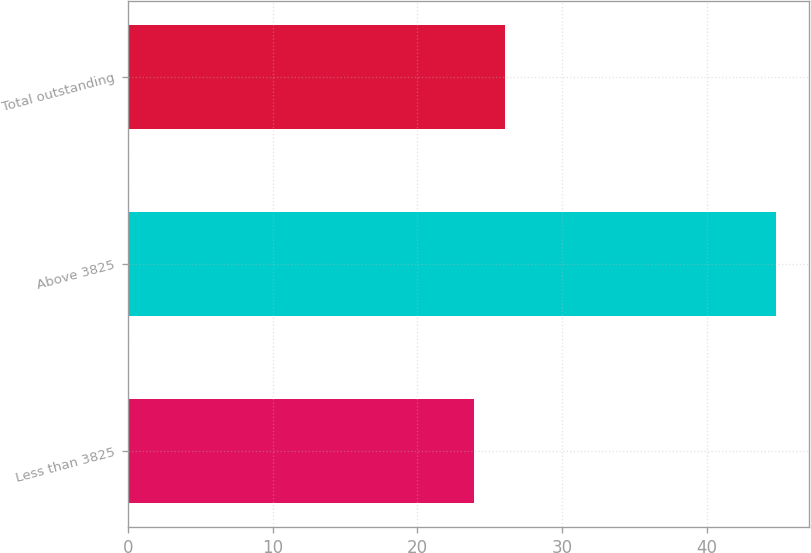<chart> <loc_0><loc_0><loc_500><loc_500><bar_chart><fcel>Less than 3825<fcel>Above 3825<fcel>Total outstanding<nl><fcel>23.94<fcel>44.81<fcel>26.03<nl></chart> 